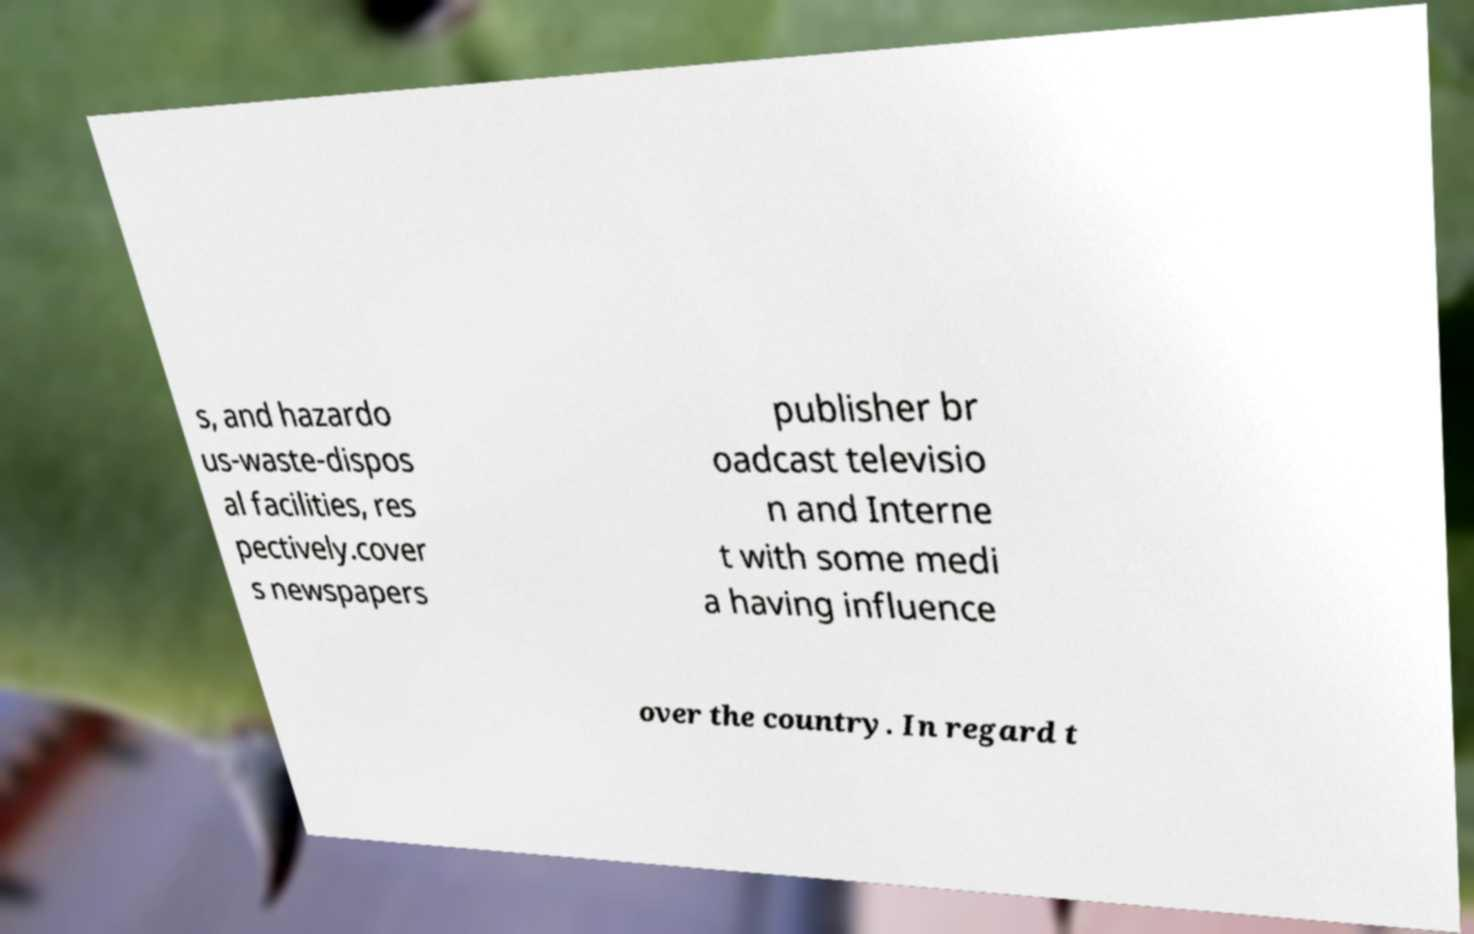Could you extract and type out the text from this image? s, and hazardo us-waste-dispos al facilities, res pectively.cover s newspapers publisher br oadcast televisio n and Interne t with some medi a having influence over the country. In regard t 